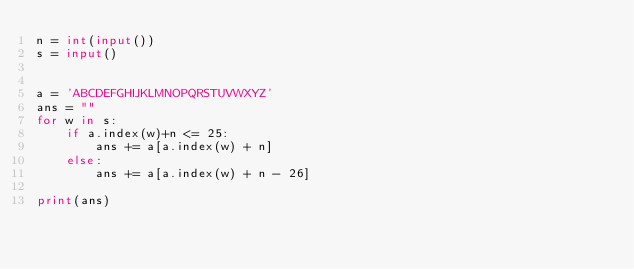<code> <loc_0><loc_0><loc_500><loc_500><_Python_>n = int(input())
s = input()


a = 'ABCDEFGHIJKLMNOPQRSTUVWXYZ'
ans = ""
for w in s:
    if a.index(w)+n <= 25:
        ans += a[a.index(w) + n]
    else:
        ans += a[a.index(w) + n - 26]

print(ans)</code> 